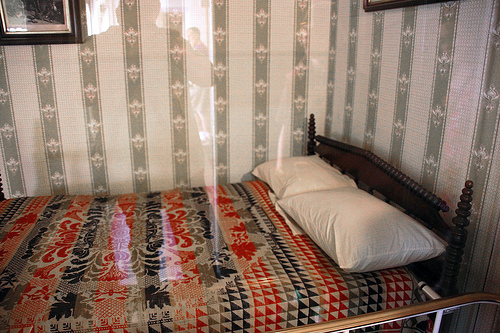What color is the pillow on the right side? The pillow on the right side of the bed is white, contrasting subtly with the colorful, patterned quilt covering the bed. 